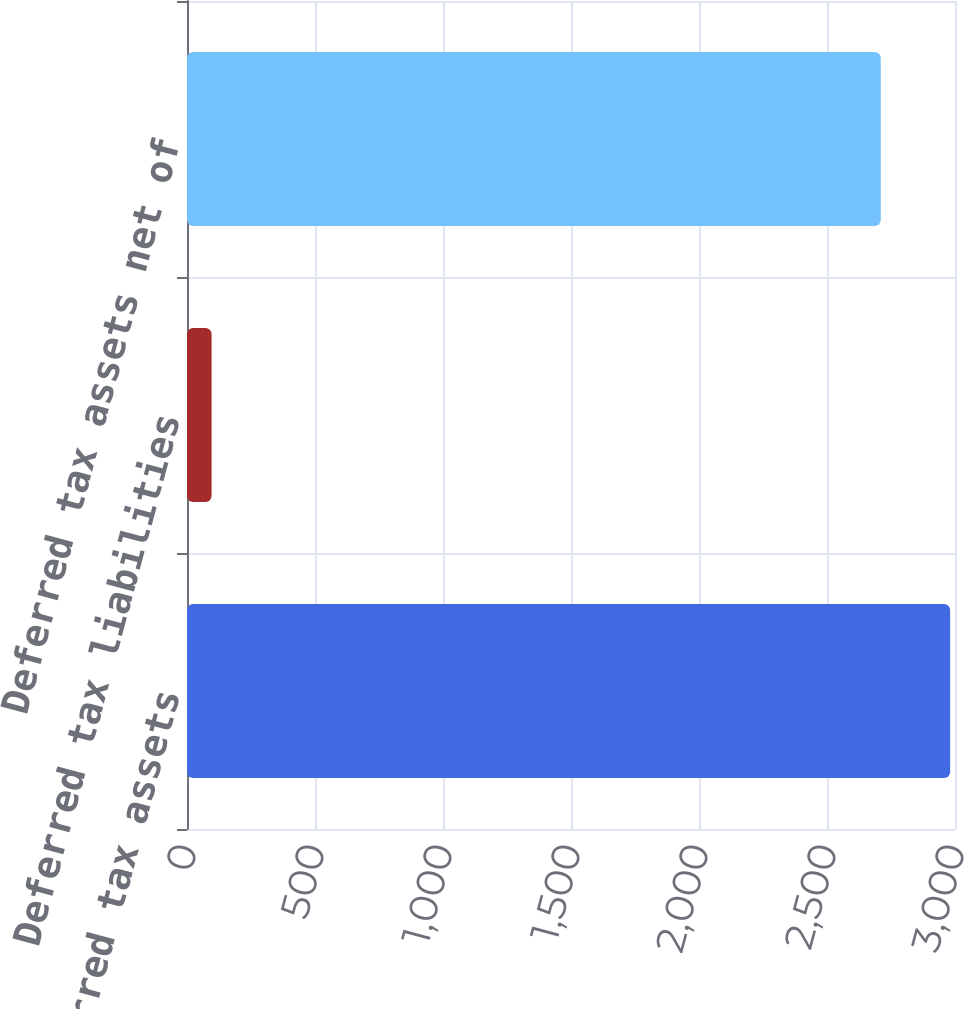<chart> <loc_0><loc_0><loc_500><loc_500><bar_chart><fcel>Deferred tax assets<fcel>Deferred tax liabilities<fcel>Deferred tax assets net of<nl><fcel>2981<fcel>96<fcel>2710<nl></chart> 